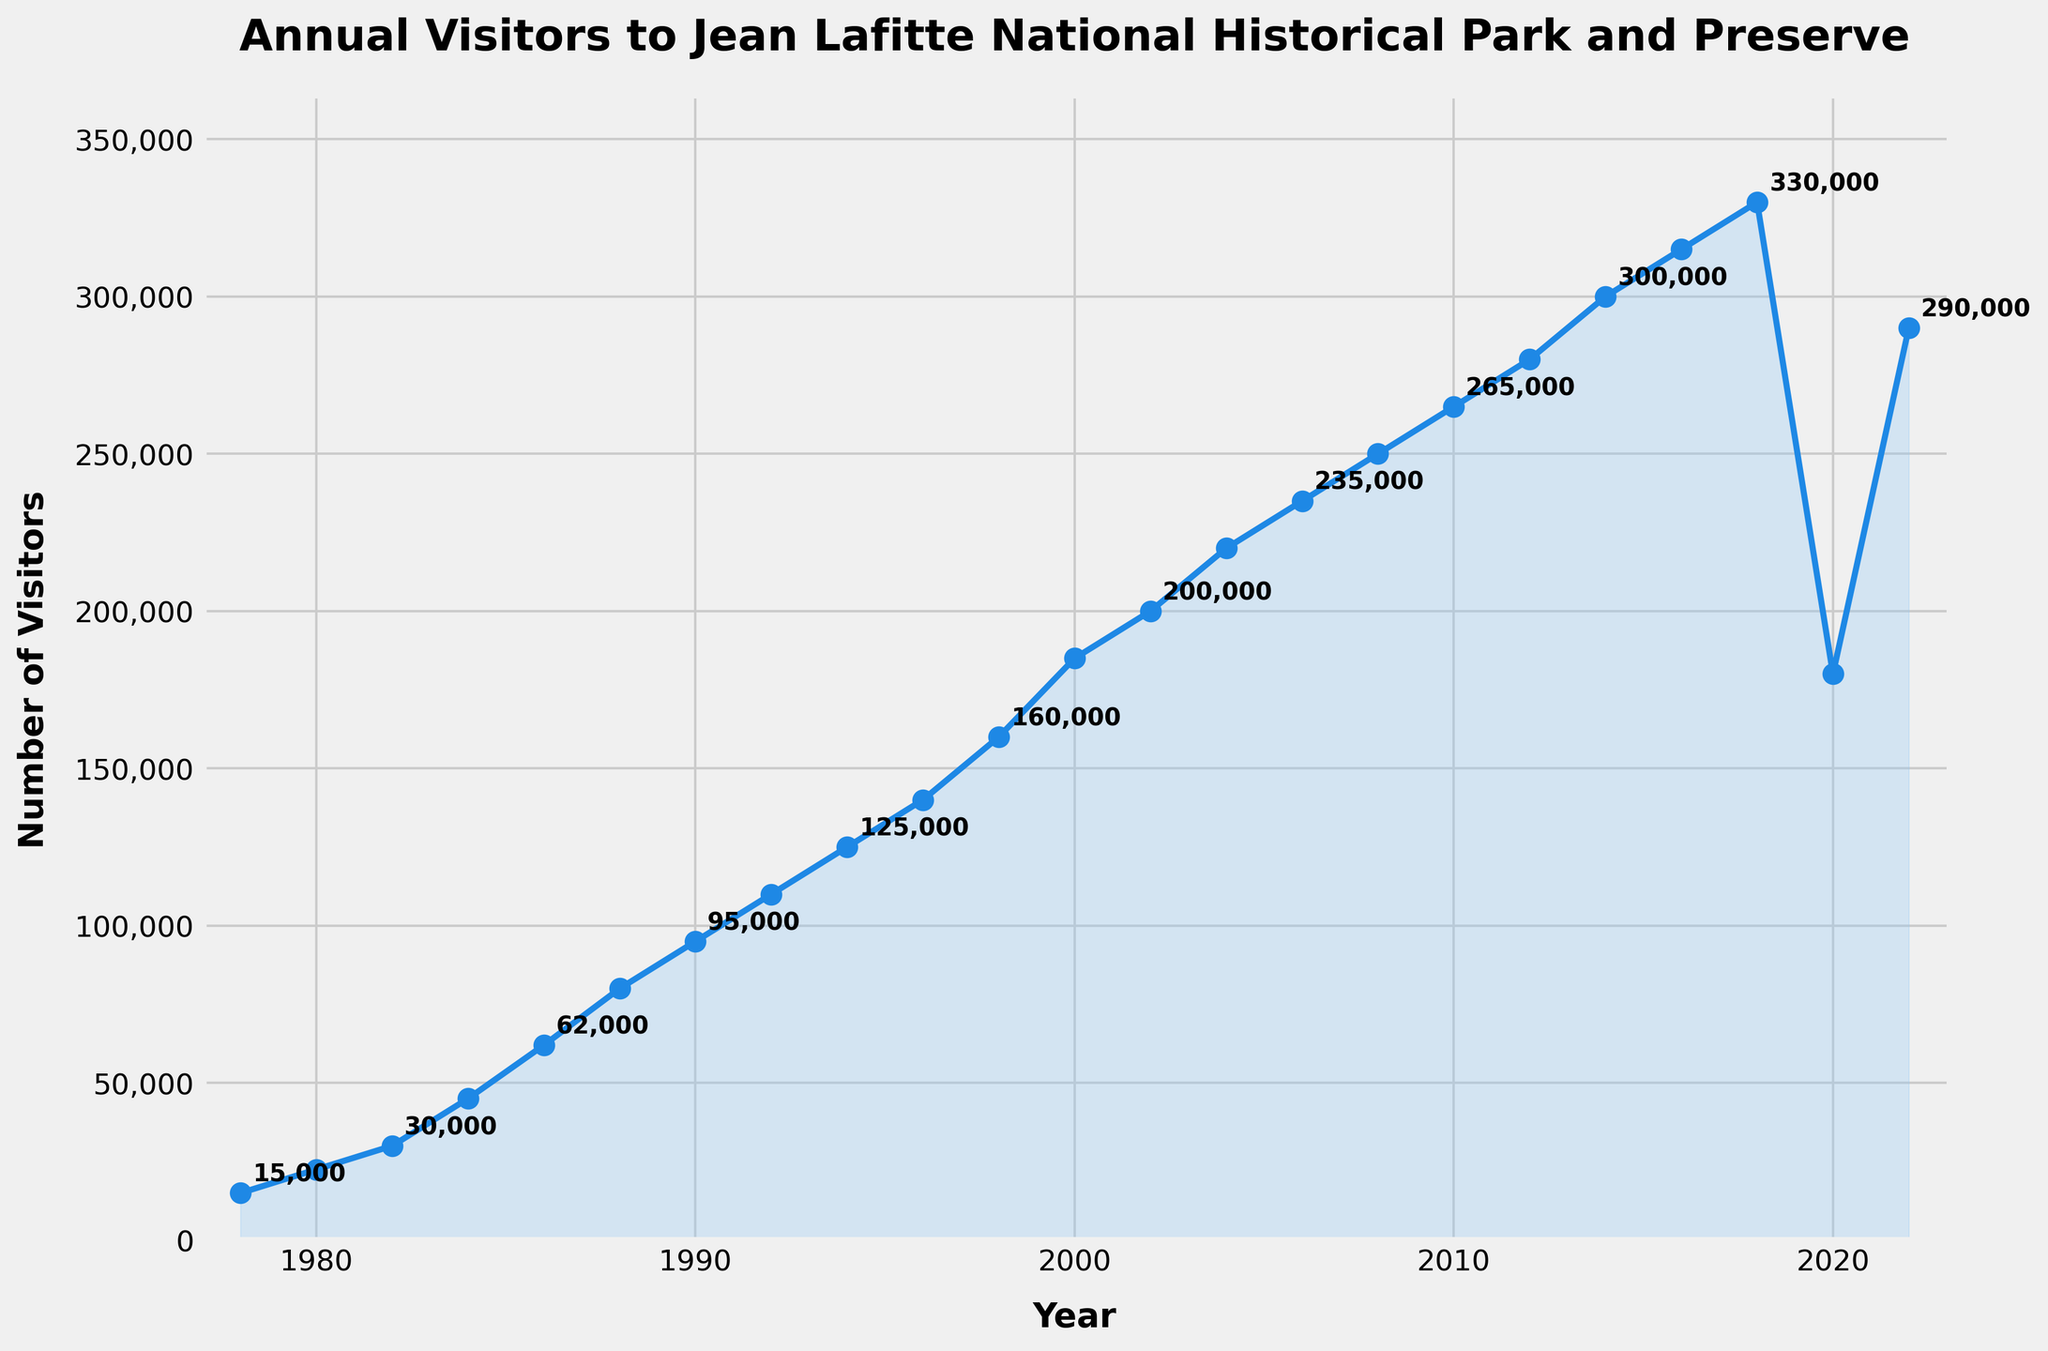What was the number of visitors in 2018? To find the number of visitors in 2018, locate the point on the line chart corresponding to the year 2018 and observe its value.
Answer: 330,000 How does the number of visitors in 2022 compare to that in 2020? Compare the values of the data points for the years 2020 and 2022. In 2020, there were 180,000 visitors, while in 2022, there were 290,000 visitors.
Answer: The number of visitors in 2022 is greater than in 2020 What is the average number of visitors from 1978 to 2022? Sum the visitor numbers for each listed year from 1978 to 2022 (3,715,000) and divide by the number of years listed (23).
Answer: 161,303 Which year experienced the highest number of visitors, and what was the number? Identify the highest point on the chart, which occurs in 2018, and note the corresponding value.
Answer: 2018 with 330,000 visitors How much did the number of visitors increase from 1978 to 2022? Subtract the number of visitors in 1978 (15,000) from the number of visitors in 2022 (290,000).
Answer: 275,000 In which year did the number of visitors first reach over 100,000? Scan the data points to identify the first year where the number exceeds 100,000, which is in 1992.
Answer: 1992 How many more visitors were there in 2000 compared to 1986? Subtract the number of visitors in 1986 (62,000) from the number of visitors in 2000 (185,000).
Answer: 123,000 What is the total increase in visitors from 1980 to 1990? Subtract the number of visitors in 1980 (22,500) from the number of visitors in 1990 (95,000).
Answer: 72,500 Identify years where visitor numbers increased by at least 50,000 compared to the previous data point. Compare each successive pair of years. The years that meet this criterion are 1984 (45,000 from 30,000 in 1982), 1986 (62,000 from 45,000 in 1984), and 2004 (220,000 from 200,000 in 2002).
Answer: 1984, 1986, 2004 What trends can be observed in visitor numbers over time? The chart shows a general upward trend in visitor numbers from 1978 to 2018, with a notable decline in 2020 due to an unspecified event, followed by a recovery in 2022.
Answer: Upward trend with a decline in 2020 